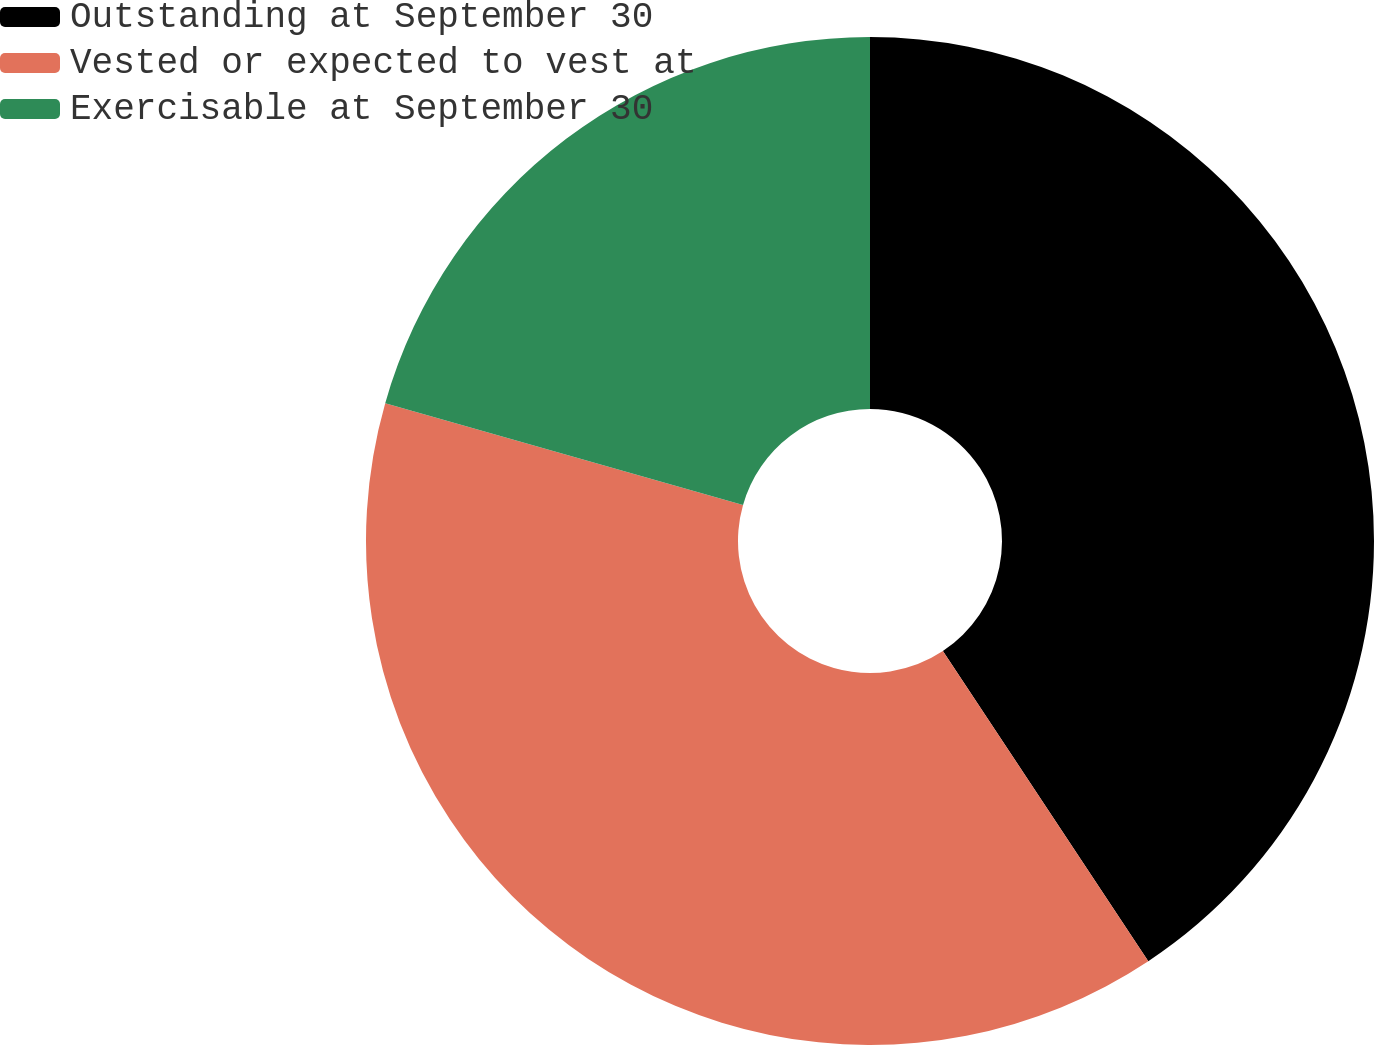Convert chart to OTSL. <chart><loc_0><loc_0><loc_500><loc_500><pie_chart><fcel>Outstanding at September 30<fcel>Vested or expected to vest at<fcel>Exercisable at September 30<nl><fcel>40.69%<fcel>38.72%<fcel>20.59%<nl></chart> 